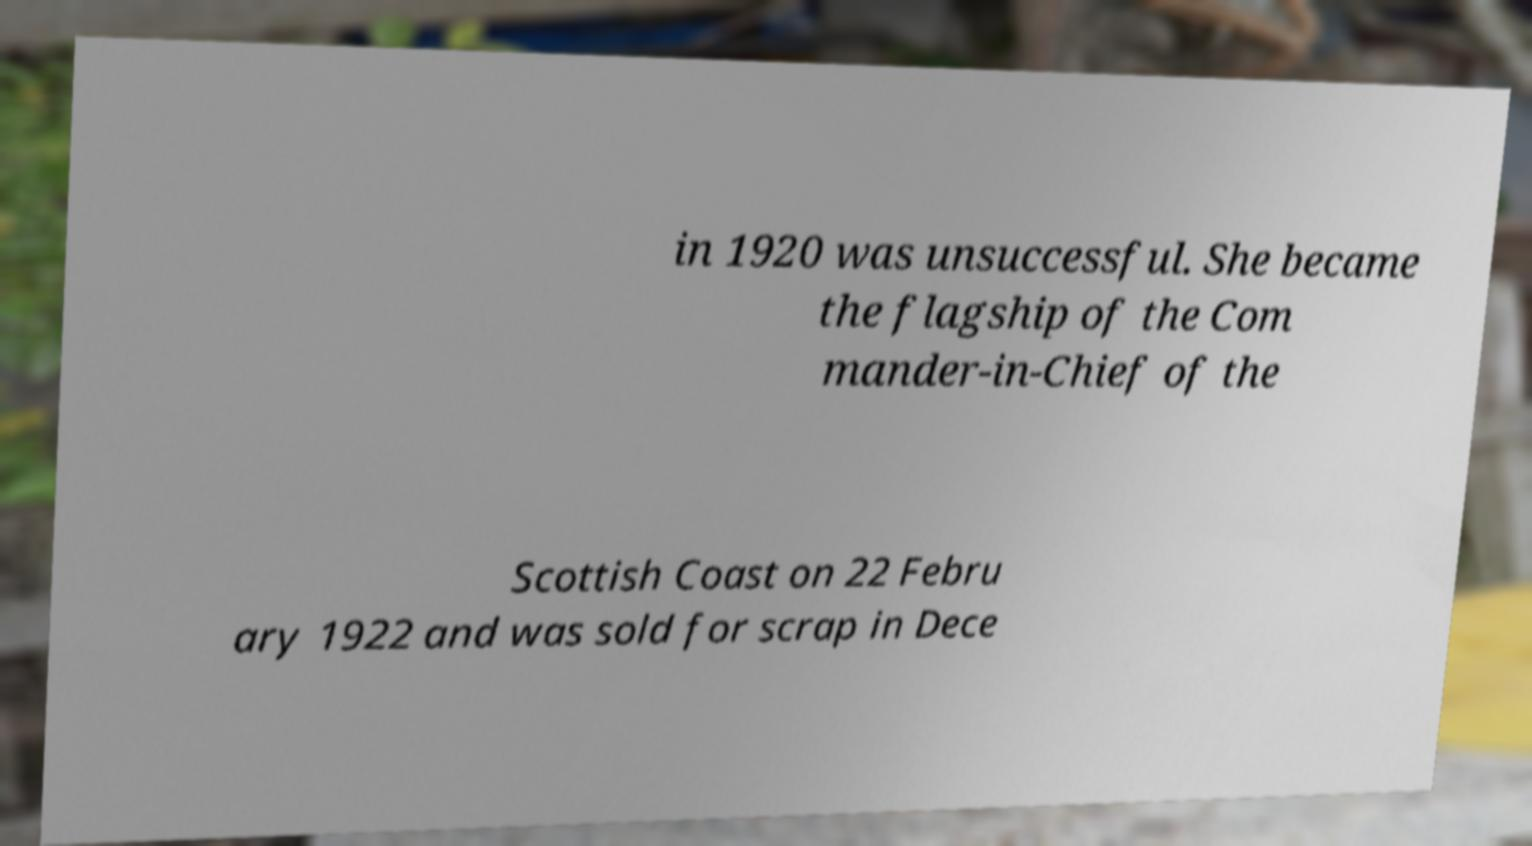For documentation purposes, I need the text within this image transcribed. Could you provide that? in 1920 was unsuccessful. She became the flagship of the Com mander-in-Chief of the Scottish Coast on 22 Febru ary 1922 and was sold for scrap in Dece 